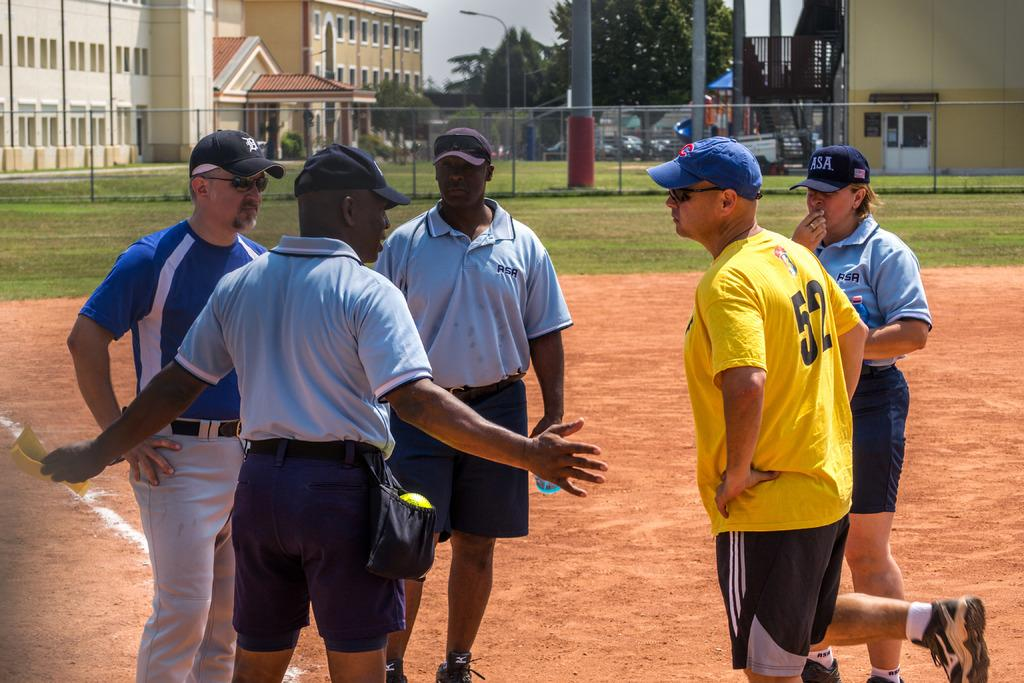<image>
Relay a brief, clear account of the picture shown. A group of guys on a field, one of whom has 52 on the back of his shirt. 